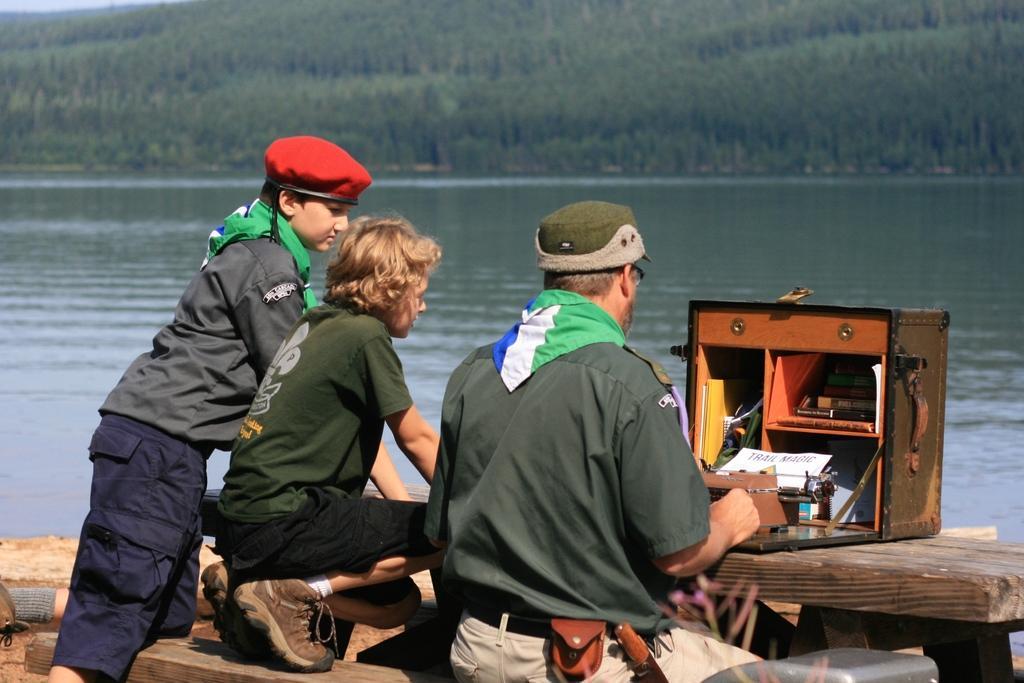Please provide a concise description of this image. In this image there are three people two of them are wearing caps, and on the right side of the image there is one box on a wooden board. In the box there are some books, papers, files and some objects. At the bottom there are some wooden sticks, and at the bottom there might be sand. And in the background there is river and some trees. 